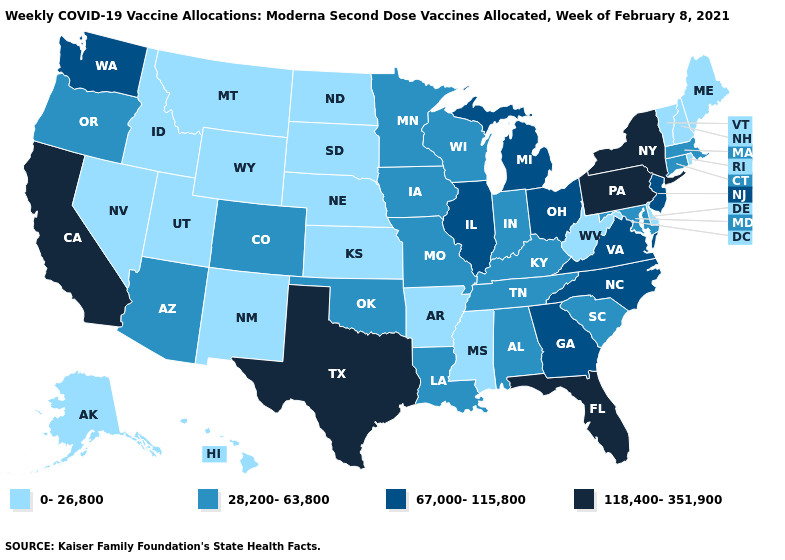What is the lowest value in the MidWest?
Keep it brief. 0-26,800. Among the states that border Delaware , does New Jersey have the highest value?
Be succinct. No. Does Kansas have the same value as Vermont?
Quick response, please. Yes. Does Texas have a higher value than New York?
Quick response, please. No. Which states hav the highest value in the South?
Short answer required. Florida, Texas. What is the value of Wyoming?
Quick response, please. 0-26,800. Among the states that border Arizona , which have the highest value?
Quick response, please. California. What is the lowest value in the USA?
Short answer required. 0-26,800. Is the legend a continuous bar?
Concise answer only. No. Among the states that border Montana , which have the highest value?
Give a very brief answer. Idaho, North Dakota, South Dakota, Wyoming. Name the states that have a value in the range 28,200-63,800?
Answer briefly. Alabama, Arizona, Colorado, Connecticut, Indiana, Iowa, Kentucky, Louisiana, Maryland, Massachusetts, Minnesota, Missouri, Oklahoma, Oregon, South Carolina, Tennessee, Wisconsin. What is the value of New Mexico?
Be succinct. 0-26,800. Which states have the highest value in the USA?
Concise answer only. California, Florida, New York, Pennsylvania, Texas. What is the lowest value in states that border Vermont?
Keep it brief. 0-26,800. What is the lowest value in the South?
Answer briefly. 0-26,800. 